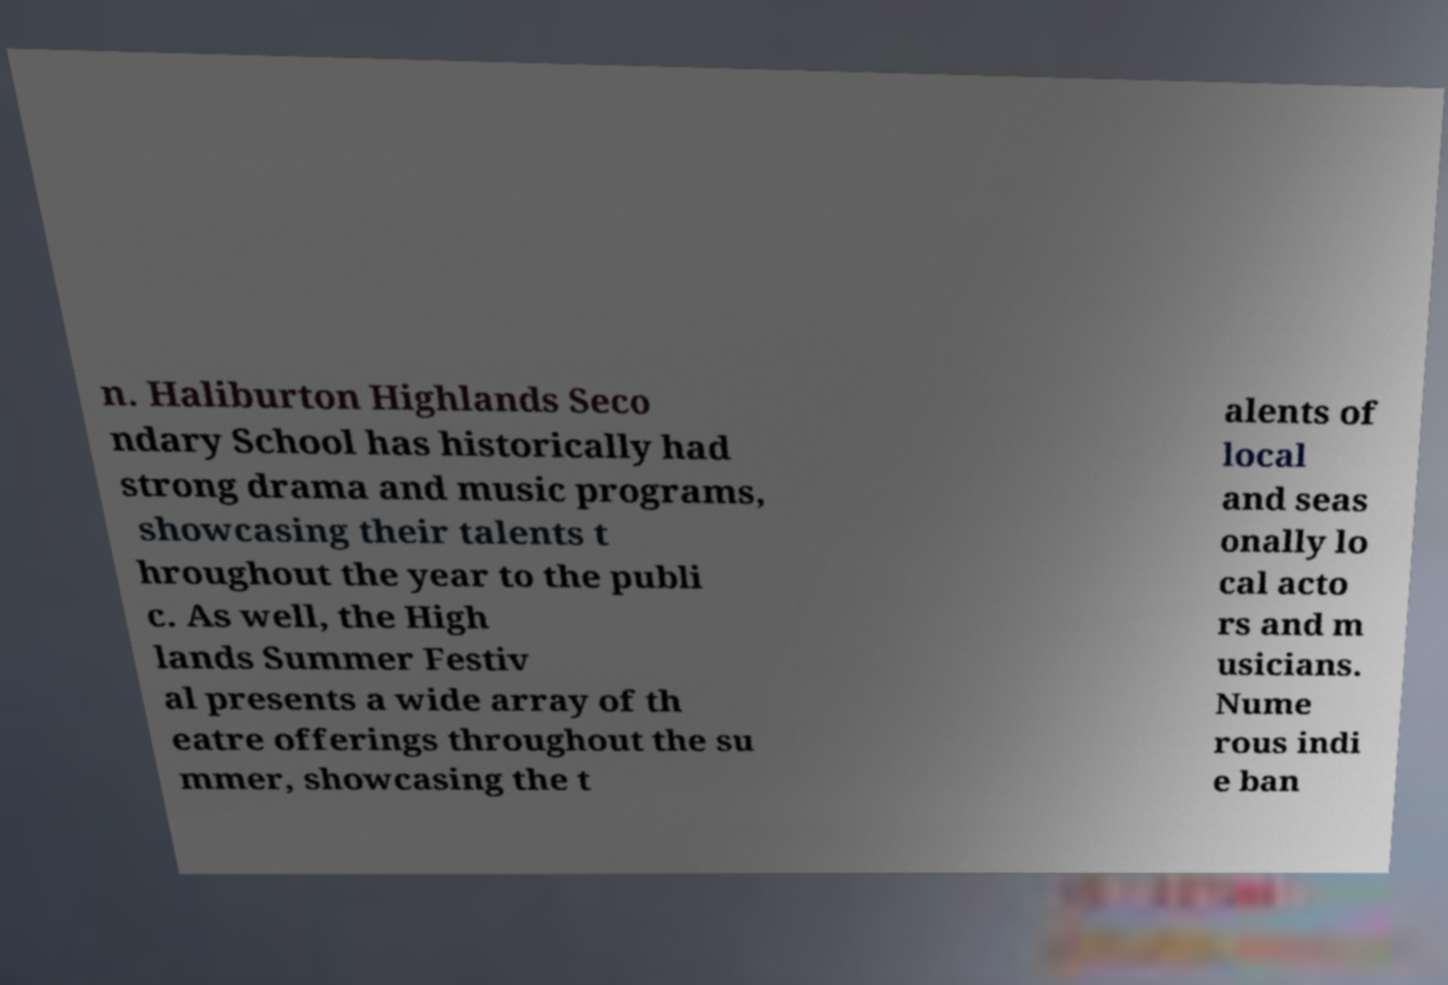Can you read and provide the text displayed in the image?This photo seems to have some interesting text. Can you extract and type it out for me? n. Haliburton Highlands Seco ndary School has historically had strong drama and music programs, showcasing their talents t hroughout the year to the publi c. As well, the High lands Summer Festiv al presents a wide array of th eatre offerings throughout the su mmer, showcasing the t alents of local and seas onally lo cal acto rs and m usicians. Nume rous indi e ban 